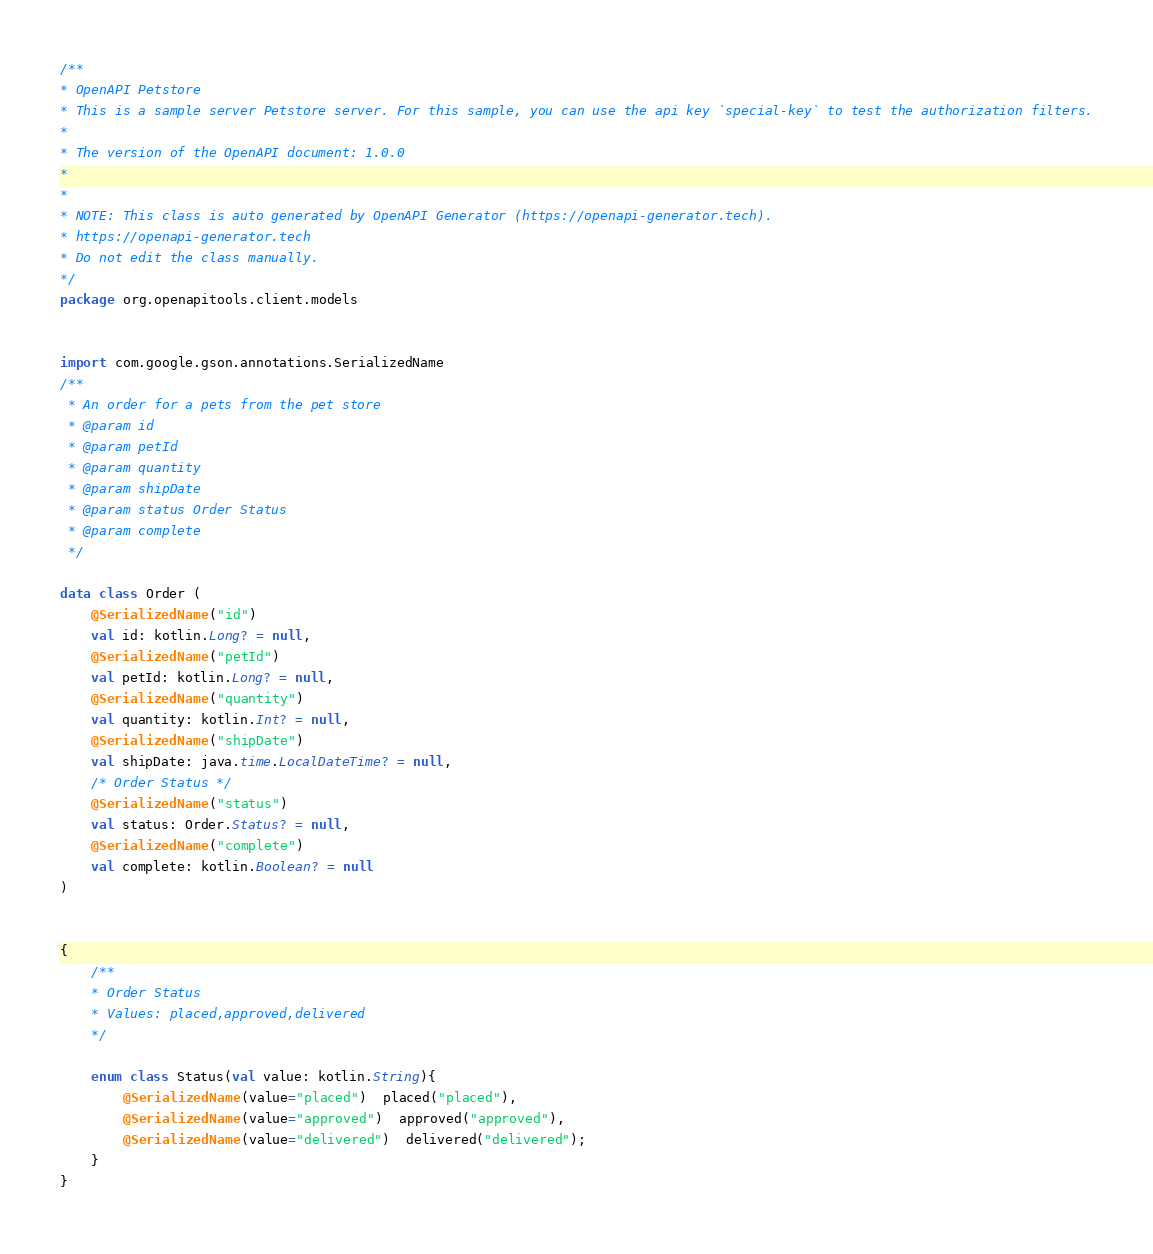Convert code to text. <code><loc_0><loc_0><loc_500><loc_500><_Kotlin_>/**
* OpenAPI Petstore
* This is a sample server Petstore server. For this sample, you can use the api key `special-key` to test the authorization filters.
*
* The version of the OpenAPI document: 1.0.0
* 
*
* NOTE: This class is auto generated by OpenAPI Generator (https://openapi-generator.tech).
* https://openapi-generator.tech
* Do not edit the class manually.
*/
package org.openapitools.client.models


import com.google.gson.annotations.SerializedName
/**
 * An order for a pets from the pet store
 * @param id 
 * @param petId 
 * @param quantity 
 * @param shipDate 
 * @param status Order Status
 * @param complete 
 */

data class Order (
    @SerializedName("id")
    val id: kotlin.Long? = null,
    @SerializedName("petId")
    val petId: kotlin.Long? = null,
    @SerializedName("quantity")
    val quantity: kotlin.Int? = null,
    @SerializedName("shipDate")
    val shipDate: java.time.LocalDateTime? = null,
    /* Order Status */
    @SerializedName("status")
    val status: Order.Status? = null,
    @SerializedName("complete")
    val complete: kotlin.Boolean? = null
) 


{
    /**
    * Order Status
    * Values: placed,approved,delivered
    */
    
    enum class Status(val value: kotlin.String){
        @SerializedName(value="placed")  placed("placed"),
        @SerializedName(value="approved")  approved("approved"),
        @SerializedName(value="delivered")  delivered("delivered");
    }
}

</code> 